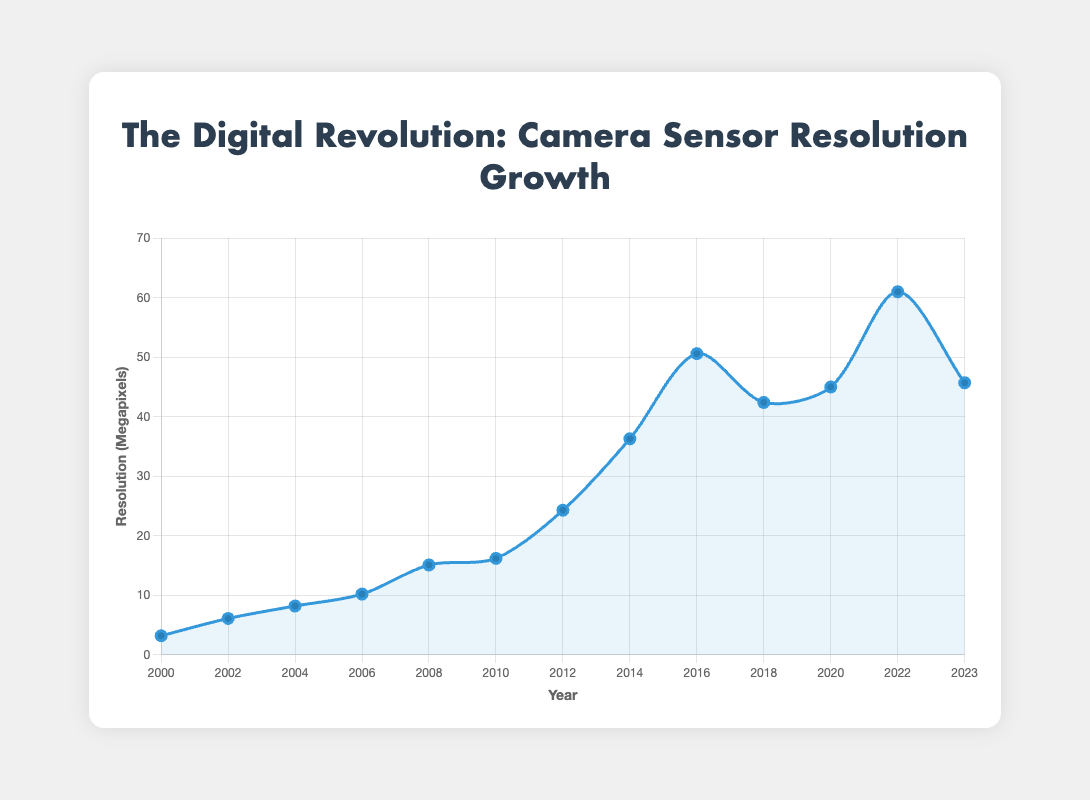What is the highest resolution camera shown in the figure, and what year was it released? By examining the line chart, we observe the peak point on the curve. The highest value corresponds to the year 2022 with a resolution of 61 megapixels.
Answer: Sony A7R IV in 2022 How much did the resolution improve from the Canon PowerShot S1 IS in 2000 to the Canon EOS-1D Mark II in 2004? Locate the points for the Canon PowerShot S1 IS (2000) and the Canon EOS-1D Mark II (2004). Their resolutions are 3.2 and 8.2 megapixels, respectively. The improvement is calculated as 8.2 - 3.2 = 5 megapixels.
Answer: 5 megapixels Which year saw the biggest jump in resolution and what was the change? By identifying the years with the most significant changes in height between consecutive points, we see the jump from 2012 (24.3 MP) to 2014 (36.3 MP), which amounts to a resolution change of 36.3 - 24.3 = 12 MP.
Answer: 2014 with a change of 12 megapixels Are there any years where the resolution decreased, and if so, which ones? By examining the trend of the curve, no points are noted as having a decrease; each year either an increase or no change is observed, implying consistent improvement or stability in resolution values over the years.
Answer: No What is the average resolution of cameras released between 2010 and 2020? Identify and sum the resolutions for cameras from 2010 to 2020: 16.2 (2010), 24.3 (2012), 36.3 (2014), 50.6 (2016), 42.4 (2018), and 45 (2020). The total is 214.8 MP. Divide by the number of data points (6): 214.8 / 6 = 35.8 MP.
Answer: 35.8 megapixels Which camera model had a resolution closest to 40 megapixels, and in what year was it released? Compare camera resolutions to 40 megapixels. The closest is the Canon EOS R5 (45 MP) in 2020.
Answer: Canon EOS R5, 2020 How long did it take for camera resolution to double from the Canon PowerShot S1 IS in 2000? The Canon PowerShot S1 IS (2000) had a resolution of 3.2 megapixels. Doubling it results in 6.4 megapixels. The Nikon D100 in 2002 exceeded this resolution with 6.1 megapixels being closest without being doubled. Essential doubling next matched by Nikon D100.
Answer: 2 years How many cameras were released with a resolution greater than or equal to 20 megapixels? Assess points where resolution is ≥ 20 megapixels: Sony Alpha NEX-7 (24.3 MP, 2012), Nikon D810 (36.3 MP, 2014), Canon EOS 5DS (50.6 MP, 2016), Sony A7R III (42.4 MP, 2018), Canon EOS R5 (45 MP, 2020), Sony A7R IV (61 MP, 2022), Nikon Z9 (45.7 MP, 2023). There are 7 such models.
Answer: 7 cameras By how much did the resolution increase on average every two years over the entire dataset? To determine the total increase, (61 - 3.2) MP = 57.8 MP over 23 years. Calculate the average increase every 2 years: (57.8 / (23 / 2)) = 57.8 / 11.5 ≈ 5.03 MP.
Answer: Approximately 5.03 megapixels Which camera model introduced in 2016, had a resolution significantly higher compared to its immediate predecessor, and by how much? Locate the 2016 mark, Canon EOS 5DS with 50.6 MP. Compare with the immediate predecessor Sony Alpha NEX-7 in 2012, 24.3 MP. The increase is 50.6 - 24.3 = 26.3 MP.
Answer: Canon EOS 5DS with an increase of 26.3 megapixels 